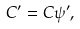Convert formula to latex. <formula><loc_0><loc_0><loc_500><loc_500>C ^ { \prime } = C \psi ^ { \prime } ,</formula> 